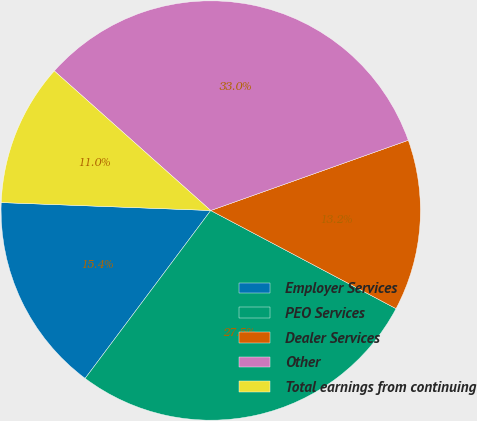Convert chart. <chart><loc_0><loc_0><loc_500><loc_500><pie_chart><fcel>Employer Services<fcel>PEO Services<fcel>Dealer Services<fcel>Other<fcel>Total earnings from continuing<nl><fcel>15.38%<fcel>27.47%<fcel>13.19%<fcel>32.97%<fcel>10.99%<nl></chart> 